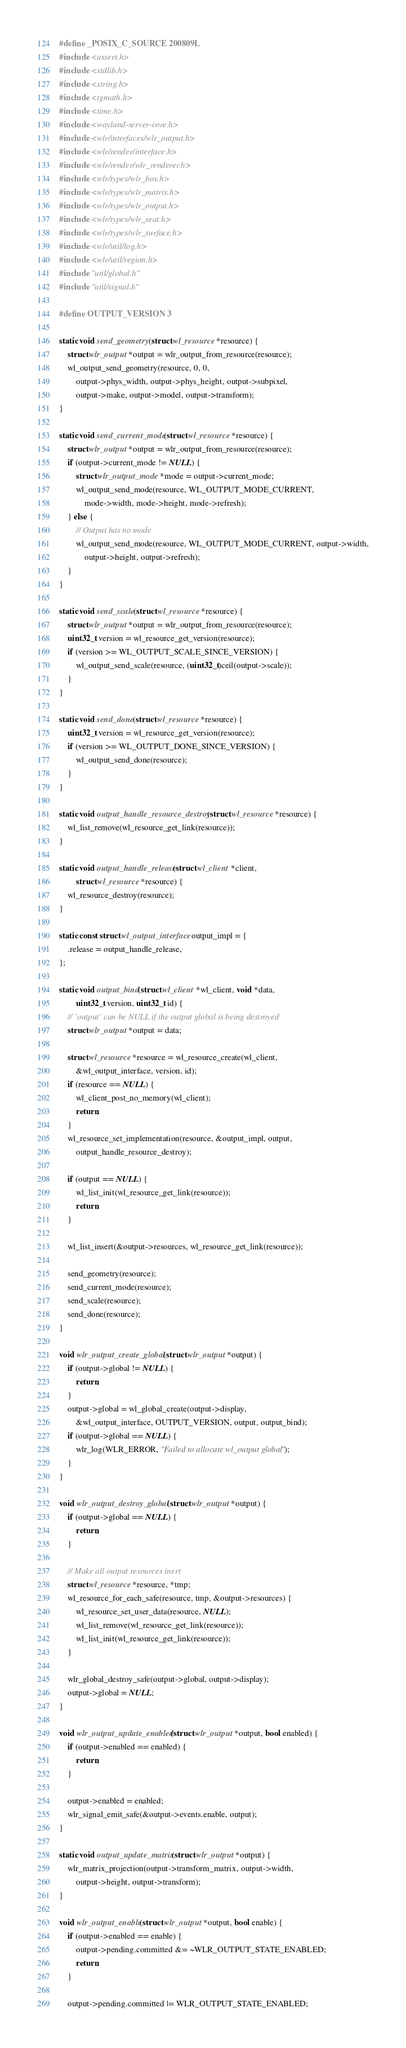<code> <loc_0><loc_0><loc_500><loc_500><_C_>#define _POSIX_C_SOURCE 200809L
#include <assert.h>
#include <stdlib.h>
#include <string.h>
#include <tgmath.h>
#include <time.h>
#include <wayland-server-core.h>
#include <wlr/interfaces/wlr_output.h>
#include <wlr/render/interface.h>
#include <wlr/render/wlr_renderer.h>
#include <wlr/types/wlr_box.h>
#include <wlr/types/wlr_matrix.h>
#include <wlr/types/wlr_output.h>
#include <wlr/types/wlr_seat.h>
#include <wlr/types/wlr_surface.h>
#include <wlr/util/log.h>
#include <wlr/util/region.h>
#include "util/global.h"
#include "util/signal.h"

#define OUTPUT_VERSION 3

static void send_geometry(struct wl_resource *resource) {
	struct wlr_output *output = wlr_output_from_resource(resource);
	wl_output_send_geometry(resource, 0, 0,
		output->phys_width, output->phys_height, output->subpixel,
		output->make, output->model, output->transform);
}

static void send_current_mode(struct wl_resource *resource) {
	struct wlr_output *output = wlr_output_from_resource(resource);
	if (output->current_mode != NULL) {
		struct wlr_output_mode *mode = output->current_mode;
		wl_output_send_mode(resource, WL_OUTPUT_MODE_CURRENT,
			mode->width, mode->height, mode->refresh);
	} else {
		// Output has no mode
		wl_output_send_mode(resource, WL_OUTPUT_MODE_CURRENT, output->width,
			output->height, output->refresh);
	}
}

static void send_scale(struct wl_resource *resource) {
	struct wlr_output *output = wlr_output_from_resource(resource);
	uint32_t version = wl_resource_get_version(resource);
	if (version >= WL_OUTPUT_SCALE_SINCE_VERSION) {
		wl_output_send_scale(resource, (uint32_t)ceil(output->scale));
	}
}

static void send_done(struct wl_resource *resource) {
	uint32_t version = wl_resource_get_version(resource);
	if (version >= WL_OUTPUT_DONE_SINCE_VERSION) {
		wl_output_send_done(resource);
	}
}

static void output_handle_resource_destroy(struct wl_resource *resource) {
	wl_list_remove(wl_resource_get_link(resource));
}

static void output_handle_release(struct wl_client *client,
		struct wl_resource *resource) {
	wl_resource_destroy(resource);
}

static const struct wl_output_interface output_impl = {
	.release = output_handle_release,
};

static void output_bind(struct wl_client *wl_client, void *data,
		uint32_t version, uint32_t id) {
	// `output` can be NULL if the output global is being destroyed
	struct wlr_output *output = data;

	struct wl_resource *resource = wl_resource_create(wl_client,
		&wl_output_interface, version, id);
	if (resource == NULL) {
		wl_client_post_no_memory(wl_client);
		return;
	}
	wl_resource_set_implementation(resource, &output_impl, output,
		output_handle_resource_destroy);

	if (output == NULL) {
		wl_list_init(wl_resource_get_link(resource));
		return;
	}

	wl_list_insert(&output->resources, wl_resource_get_link(resource));

	send_geometry(resource);
	send_current_mode(resource);
	send_scale(resource);
	send_done(resource);
}

void wlr_output_create_global(struct wlr_output *output) {
	if (output->global != NULL) {
		return;
	}
	output->global = wl_global_create(output->display,
		&wl_output_interface, OUTPUT_VERSION, output, output_bind);
	if (output->global == NULL) {
		wlr_log(WLR_ERROR, "Failed to allocate wl_output global");
	}
}

void wlr_output_destroy_global(struct wlr_output *output) {
	if (output->global == NULL) {
		return;
	}

	// Make all output resources inert
	struct wl_resource *resource, *tmp;
	wl_resource_for_each_safe(resource, tmp, &output->resources) {
		wl_resource_set_user_data(resource, NULL);
		wl_list_remove(wl_resource_get_link(resource));
		wl_list_init(wl_resource_get_link(resource));
	}

	wlr_global_destroy_safe(output->global, output->display);
	output->global = NULL;
}

void wlr_output_update_enabled(struct wlr_output *output, bool enabled) {
	if (output->enabled == enabled) {
		return;
	}

	output->enabled = enabled;
	wlr_signal_emit_safe(&output->events.enable, output);
}

static void output_update_matrix(struct wlr_output *output) {
	wlr_matrix_projection(output->transform_matrix, output->width,
		output->height, output->transform);
}

void wlr_output_enable(struct wlr_output *output, bool enable) {
	if (output->enabled == enable) {
		output->pending.committed &= ~WLR_OUTPUT_STATE_ENABLED;
		return;
	}

	output->pending.committed |= WLR_OUTPUT_STATE_ENABLED;</code> 